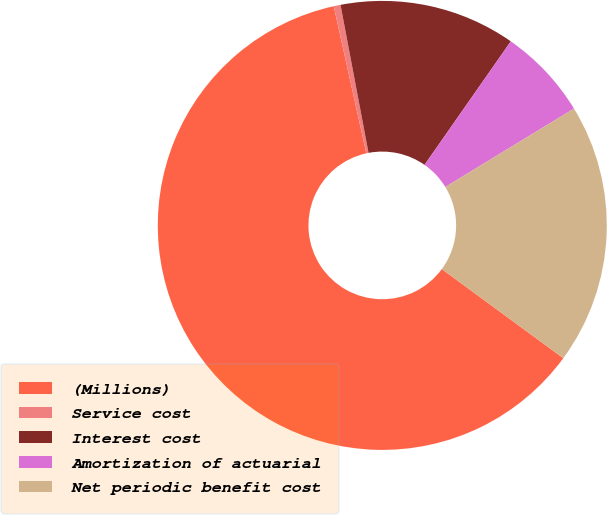Convert chart. <chart><loc_0><loc_0><loc_500><loc_500><pie_chart><fcel>(Millions)<fcel>Service cost<fcel>Interest cost<fcel>Amortization of actuarial<fcel>Net periodic benefit cost<nl><fcel>61.46%<fcel>0.49%<fcel>12.68%<fcel>6.59%<fcel>18.78%<nl></chart> 